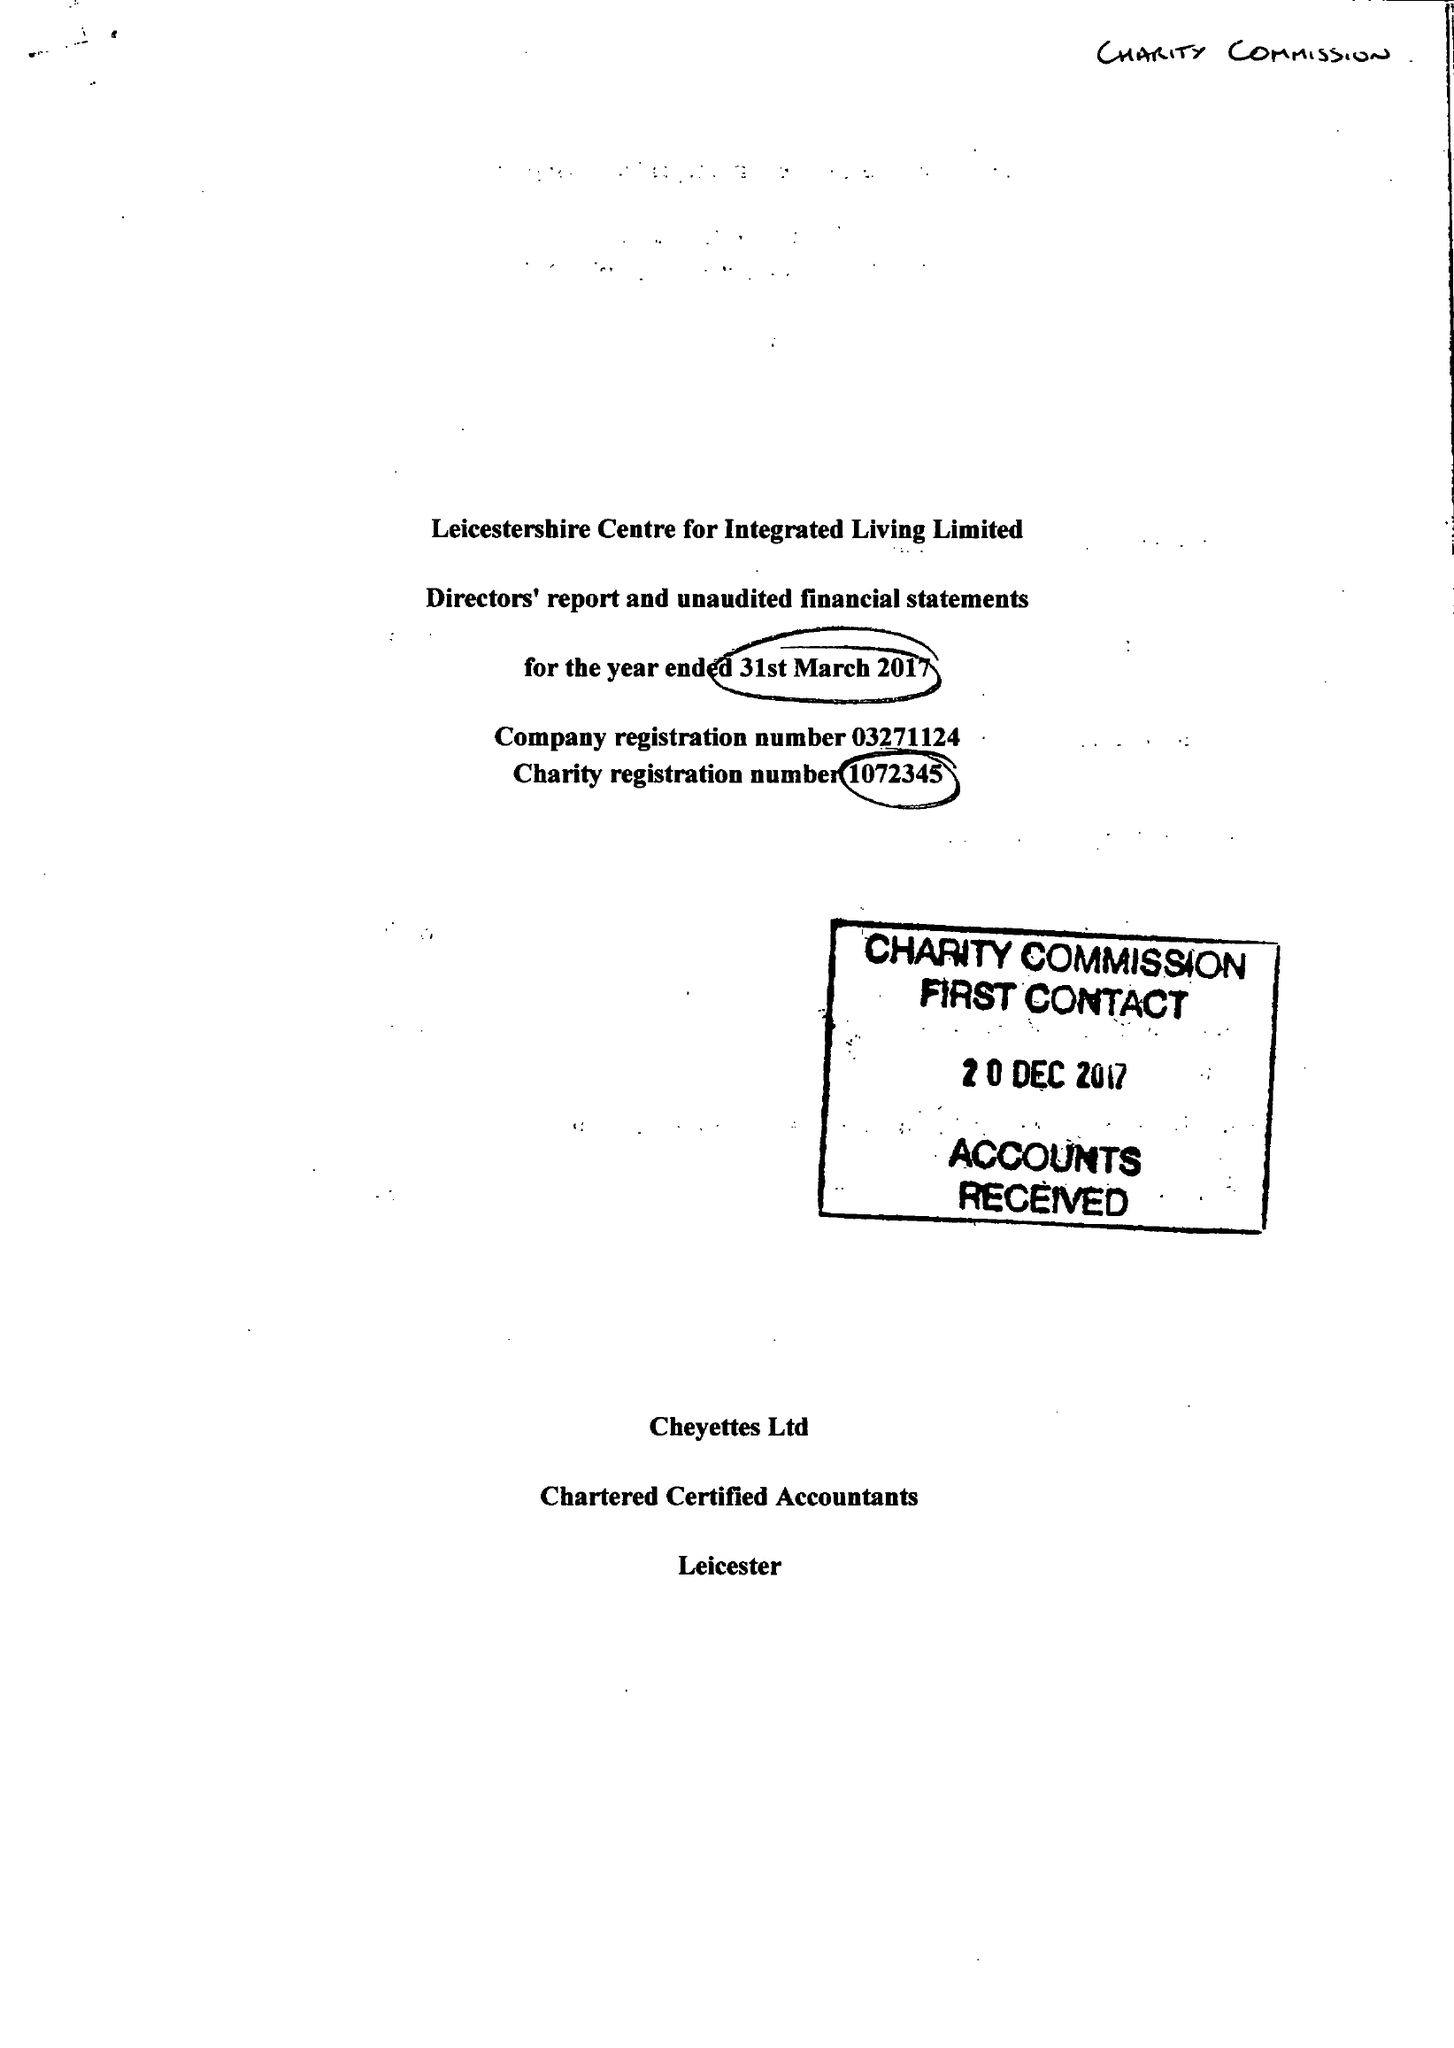What is the value for the spending_annually_in_british_pounds?
Answer the question using a single word or phrase. 118256.00 